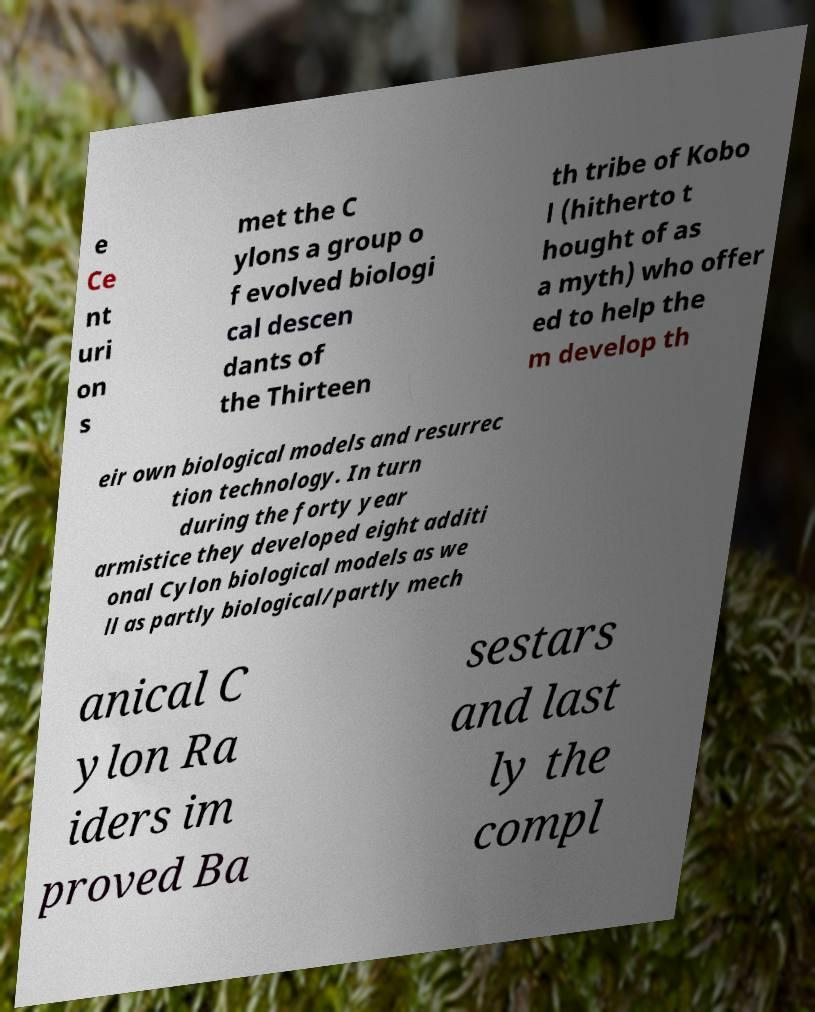Please read and relay the text visible in this image. What does it say? e Ce nt uri on s met the C ylons a group o f evolved biologi cal descen dants of the Thirteen th tribe of Kobo l (hitherto t hought of as a myth) who offer ed to help the m develop th eir own biological models and resurrec tion technology. In turn during the forty year armistice they developed eight additi onal Cylon biological models as we ll as partly biological/partly mech anical C ylon Ra iders im proved Ba sestars and last ly the compl 